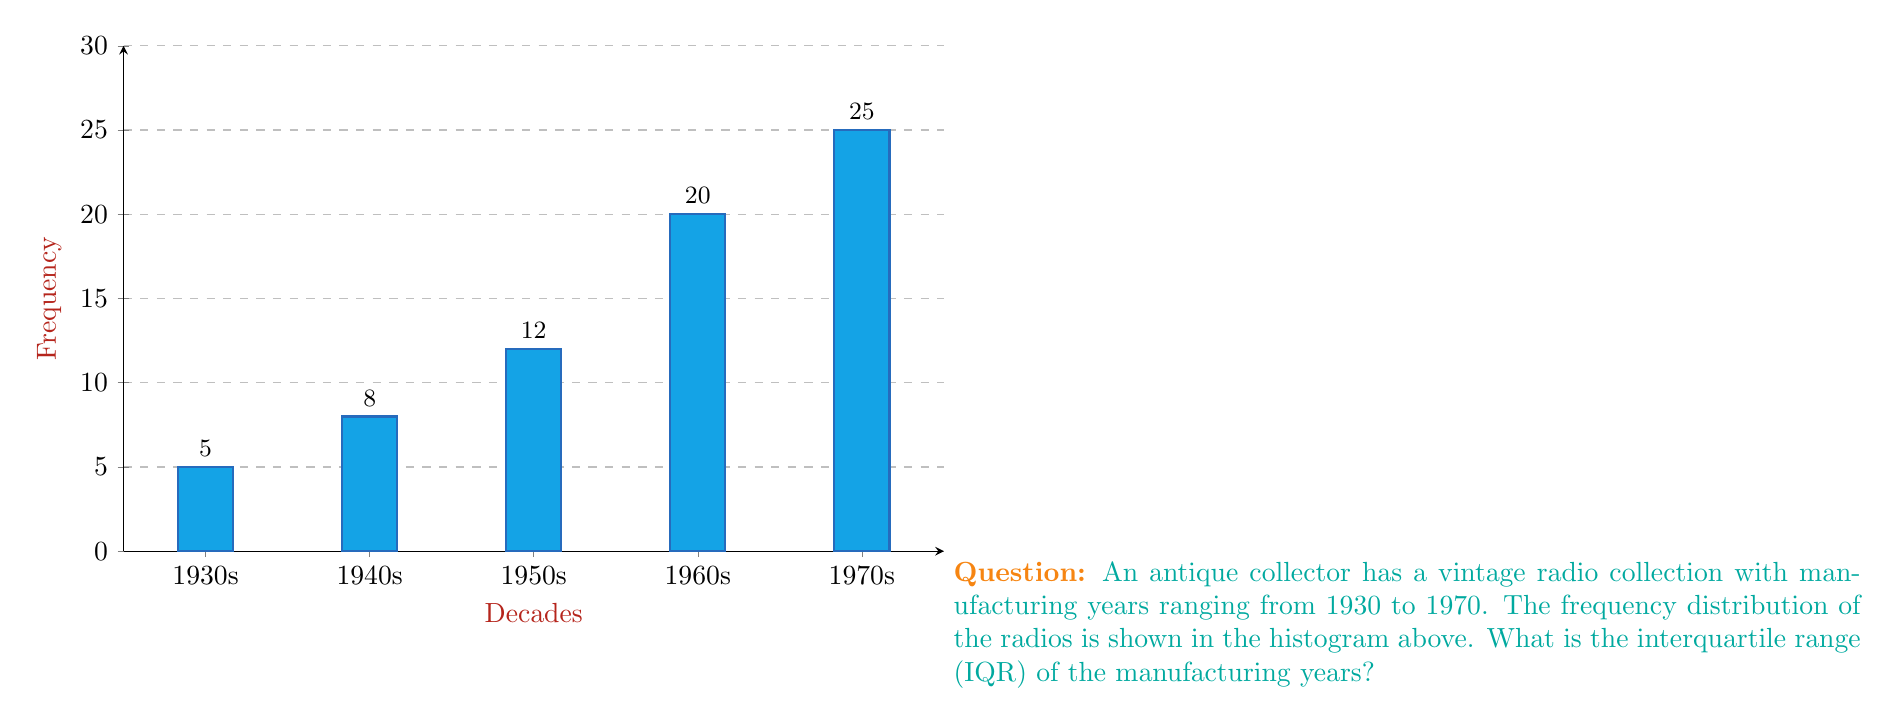What is the answer to this math problem? To find the interquartile range (IQR), we need to determine the first quartile (Q1) and the third quartile (Q3). Then, IQR = Q3 - Q1.

Step 1: Calculate the total number of radios.
Total = 5 + 8 + 12 + 20 + 25 = 70 radios

Step 2: Find the position of Q1 (25th percentile) and Q3 (75th percentile).
Q1 position = 0.25 × 70 = 17.5
Q3 position = 0.75 × 70 = 52.5

Step 3: Determine Q1 and Q3 from the cumulative frequencies.
Cumulative frequencies: 5, 13, 25, 45, 70

Q1 falls in the 1940s (13 < 17.5 < 25)
Q3 falls in the 1960s (45 < 52.5 < 70)

Step 4: Interpolate to find exact values.
Q1 = 1940 + (17.5 - 13) / (25 - 13) × 10 = 1943.75
Q3 = 1960 + (52.5 - 45) / (70 - 45) × 10 = 1963

Step 5: Calculate IQR.
IQR = Q3 - Q1 = 1963 - 1943.75 = 19.25 years
Answer: 19.25 years 